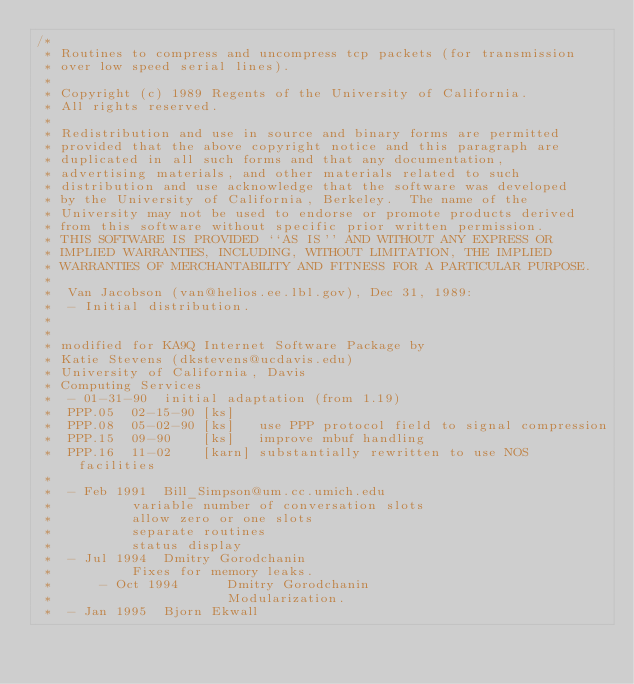<code> <loc_0><loc_0><loc_500><loc_500><_C_>/*
 * Routines to compress and uncompress tcp packets (for transmission
 * over low speed serial lines).
 *
 * Copyright (c) 1989 Regents of the University of California.
 * All rights reserved.
 *
 * Redistribution and use in source and binary forms are permitted
 * provided that the above copyright notice and this paragraph are
 * duplicated in all such forms and that any documentation,
 * advertising materials, and other materials related to such
 * distribution and use acknowledge that the software was developed
 * by the University of California, Berkeley.  The name of the
 * University may not be used to endorse or promote products derived
 * from this software without specific prior written permission.
 * THIS SOFTWARE IS PROVIDED ``AS IS'' AND WITHOUT ANY EXPRESS OR
 * IMPLIED WARRANTIES, INCLUDING, WITHOUT LIMITATION, THE IMPLIED
 * WARRANTIES OF MERCHANTABILITY AND FITNESS FOR A PARTICULAR PURPOSE.
 *
 *	Van Jacobson (van@helios.ee.lbl.gov), Dec 31, 1989:
 *	- Initial distribution.
 *
 *
 * modified for KA9Q Internet Software Package by
 * Katie Stevens (dkstevens@ucdavis.edu)
 * University of California, Davis
 * Computing Services
 *	- 01-31-90	initial adaptation (from 1.19)
 *	PPP.05	02-15-90 [ks]
 *	PPP.08	05-02-90 [ks]	use PPP protocol field to signal compression
 *	PPP.15	09-90	 [ks]	improve mbuf handling
 *	PPP.16	11-02	 [karn]	substantially rewritten to use NOS facilities
 *
 *	- Feb 1991	Bill_Simpson@um.cc.umich.edu
 *			variable number of conversation slots
 *			allow zero or one slots
 *			separate routines
 *			status display
 *	- Jul 1994	Dmitry Gorodchanin
 *			Fixes for memory leaks.
 *      - Oct 1994      Dmitry Gorodchanin
 *                      Modularization.
 *	- Jan 1995	Bjorn Ekwall</code> 